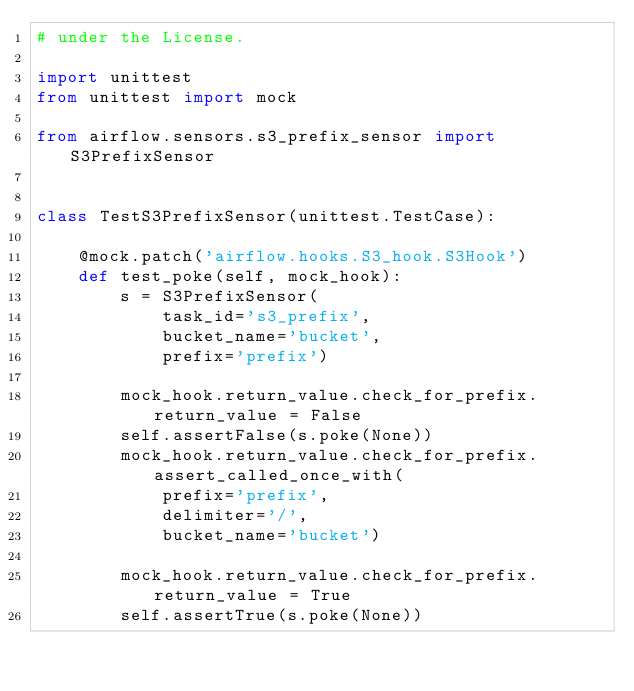<code> <loc_0><loc_0><loc_500><loc_500><_Python_># under the License.

import unittest
from unittest import mock

from airflow.sensors.s3_prefix_sensor import S3PrefixSensor


class TestS3PrefixSensor(unittest.TestCase):

    @mock.patch('airflow.hooks.S3_hook.S3Hook')
    def test_poke(self, mock_hook):
        s = S3PrefixSensor(
            task_id='s3_prefix',
            bucket_name='bucket',
            prefix='prefix')

        mock_hook.return_value.check_for_prefix.return_value = False
        self.assertFalse(s.poke(None))
        mock_hook.return_value.check_for_prefix.assert_called_once_with(
            prefix='prefix',
            delimiter='/',
            bucket_name='bucket')

        mock_hook.return_value.check_for_prefix.return_value = True
        self.assertTrue(s.poke(None))
</code> 